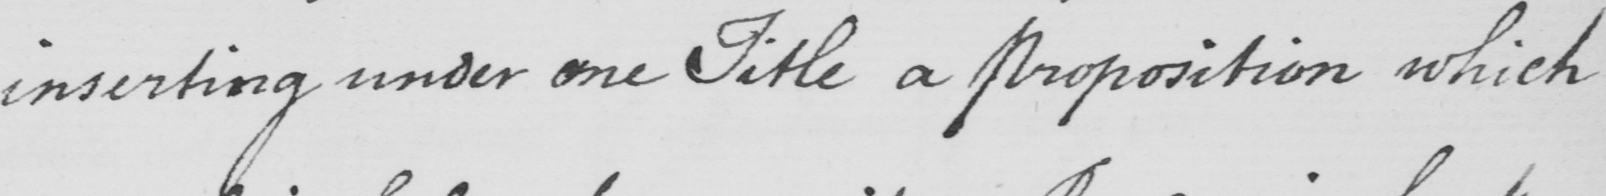What is written in this line of handwriting? inserting under one Title a proposition which 